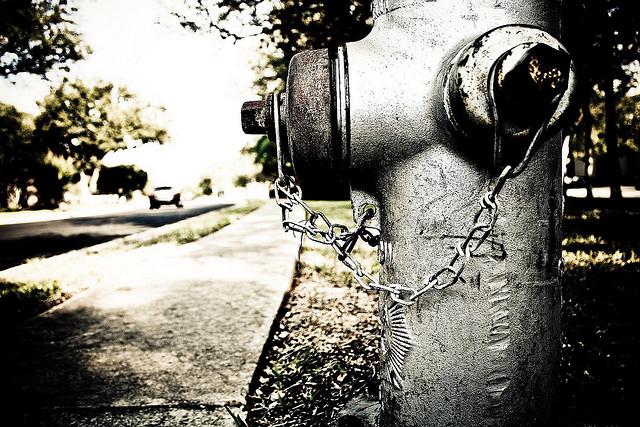How many scratch marks on this fire hydrant?
Concise answer only. 10. Is the chain for decoration?
Concise answer only. No. Can you see a car?
Give a very brief answer. Yes. 